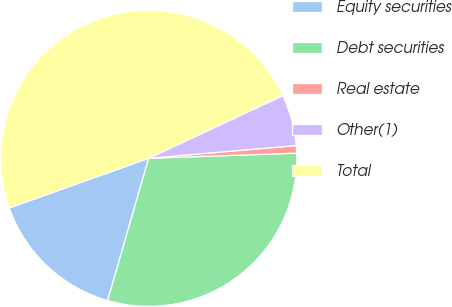Convert chart. <chart><loc_0><loc_0><loc_500><loc_500><pie_chart><fcel>Equity securities<fcel>Debt securities<fcel>Real estate<fcel>Other(1)<fcel>Total<nl><fcel>15.08%<fcel>30.02%<fcel>0.82%<fcel>5.59%<fcel>48.49%<nl></chart> 